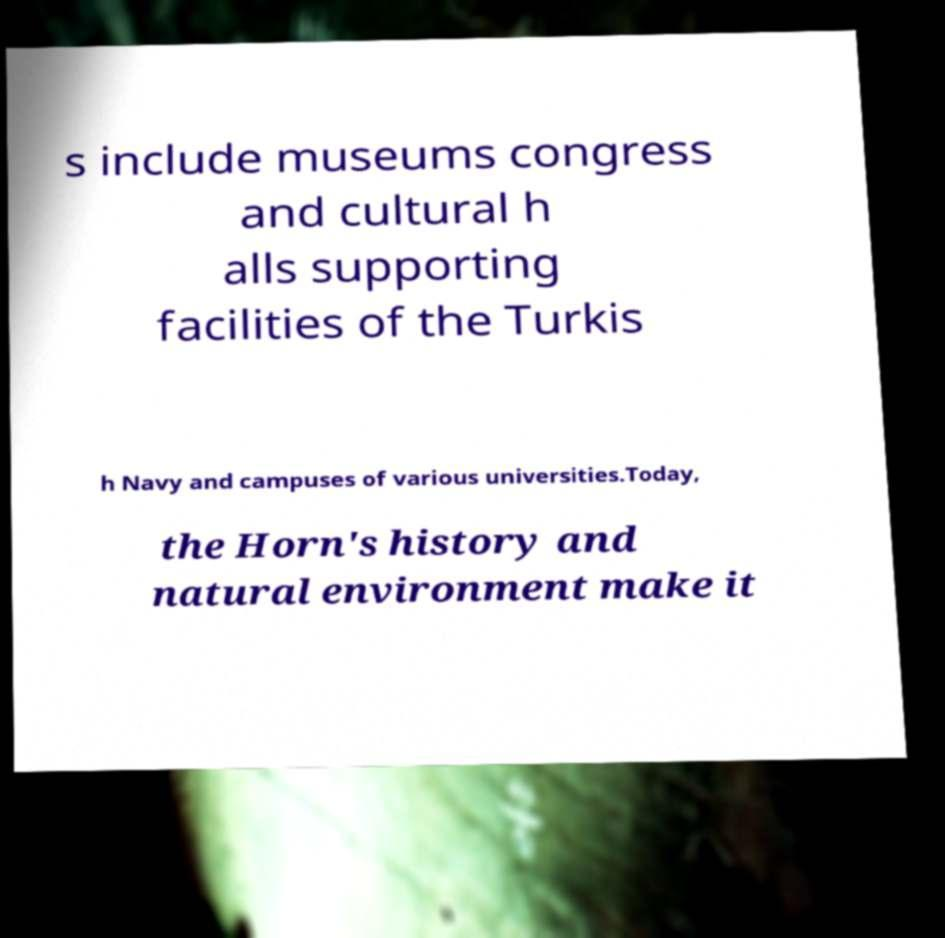I need the written content from this picture converted into text. Can you do that? s include museums congress and cultural h alls supporting facilities of the Turkis h Navy and campuses of various universities.Today, the Horn's history and natural environment make it 